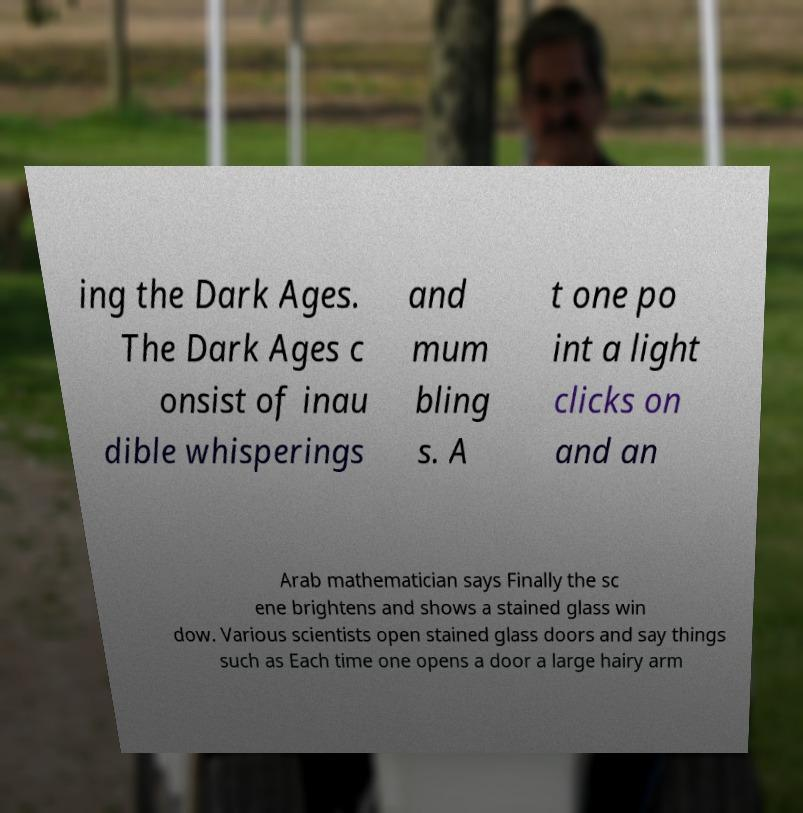Could you assist in decoding the text presented in this image and type it out clearly? ing the Dark Ages. The Dark Ages c onsist of inau dible whisperings and mum bling s. A t one po int a light clicks on and an Arab mathematician says Finally the sc ene brightens and shows a stained glass win dow. Various scientists open stained glass doors and say things such as Each time one opens a door a large hairy arm 